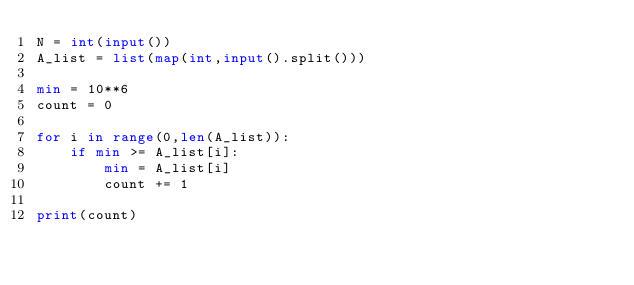<code> <loc_0><loc_0><loc_500><loc_500><_Python_>N = int(input())
A_list = list(map(int,input().split()))

min = 10**6
count = 0

for i in range(0,len(A_list)):
    if min >= A_list[i]:
        min = A_list[i]
        count += 1

print(count)</code> 